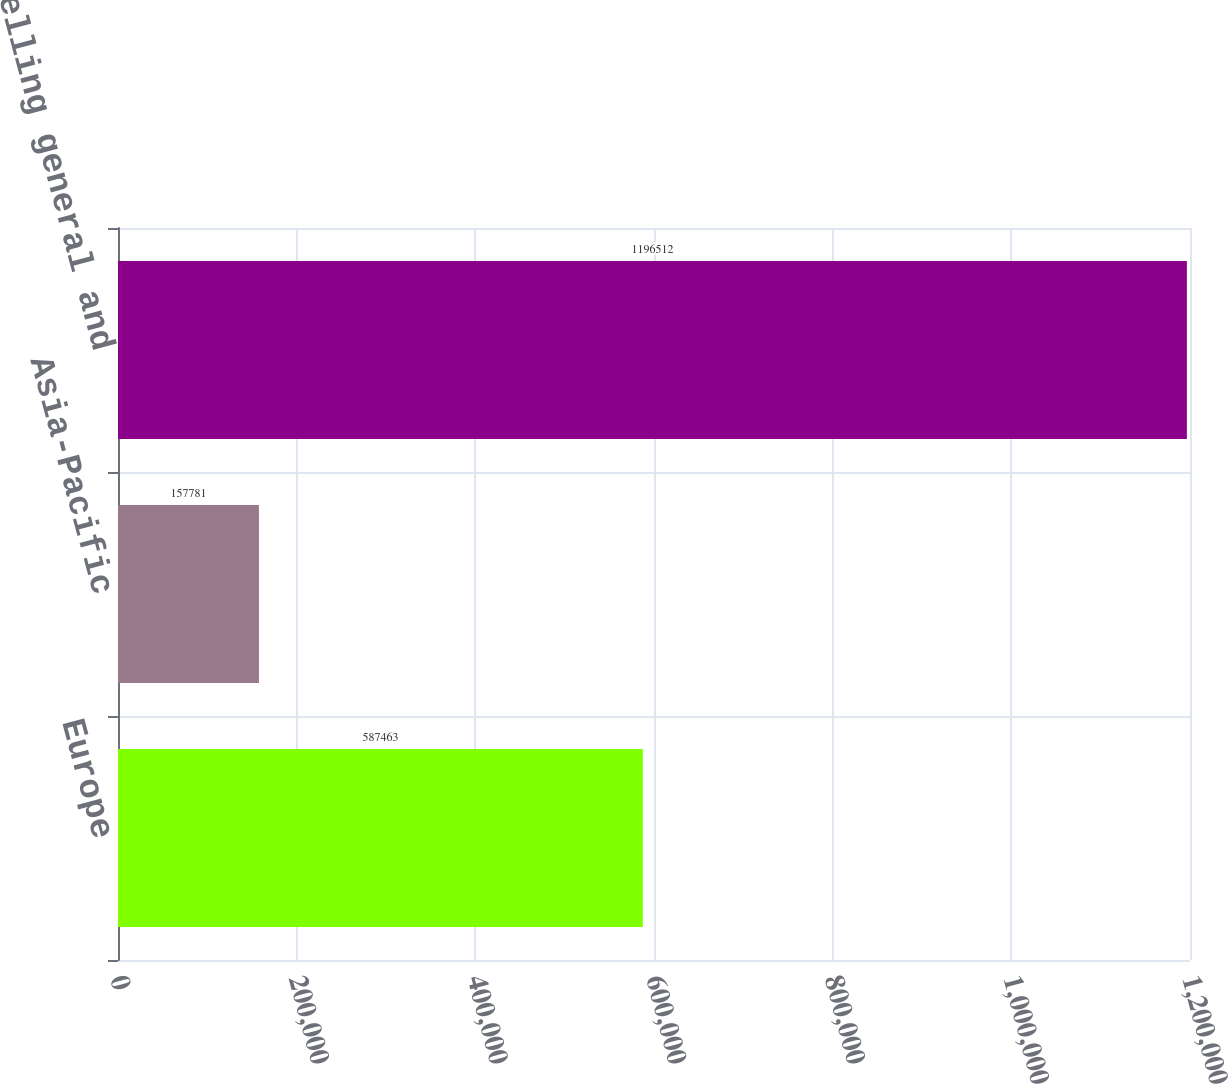Convert chart. <chart><loc_0><loc_0><loc_500><loc_500><bar_chart><fcel>Europe<fcel>Asia-Pacific<fcel>Selling general and<nl><fcel>587463<fcel>157781<fcel>1.19651e+06<nl></chart> 